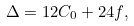Convert formula to latex. <formula><loc_0><loc_0><loc_500><loc_500>\Delta = 1 2 C _ { 0 } + 2 4 f ,</formula> 